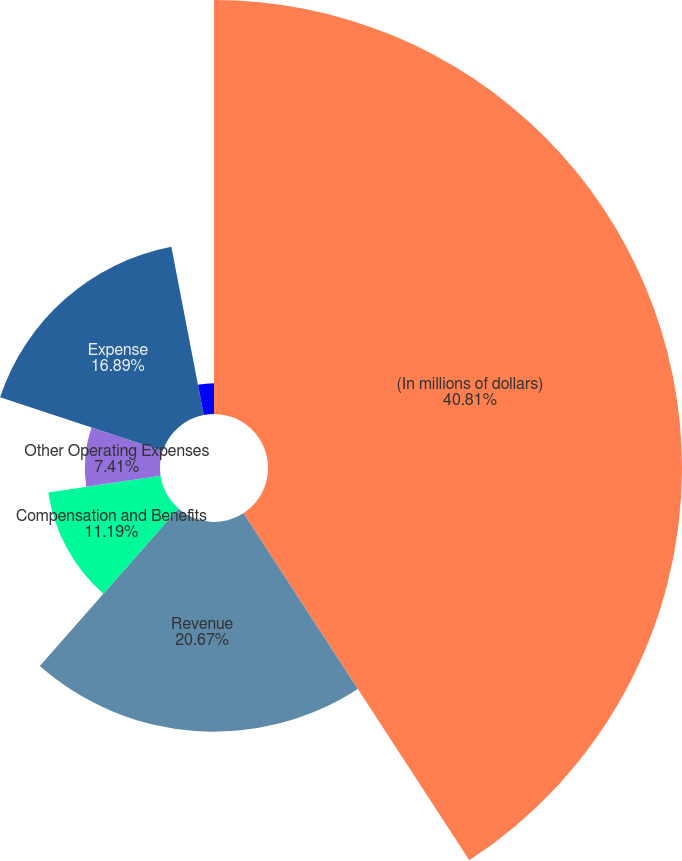Convert chart. <chart><loc_0><loc_0><loc_500><loc_500><pie_chart><fcel>(In millions of dollars)<fcel>Revenue<fcel>Compensation and Benefits<fcel>Other Operating Expenses<fcel>Expense<fcel>Operating Income<nl><fcel>40.82%<fcel>20.67%<fcel>11.19%<fcel>7.41%<fcel>16.89%<fcel>3.03%<nl></chart> 